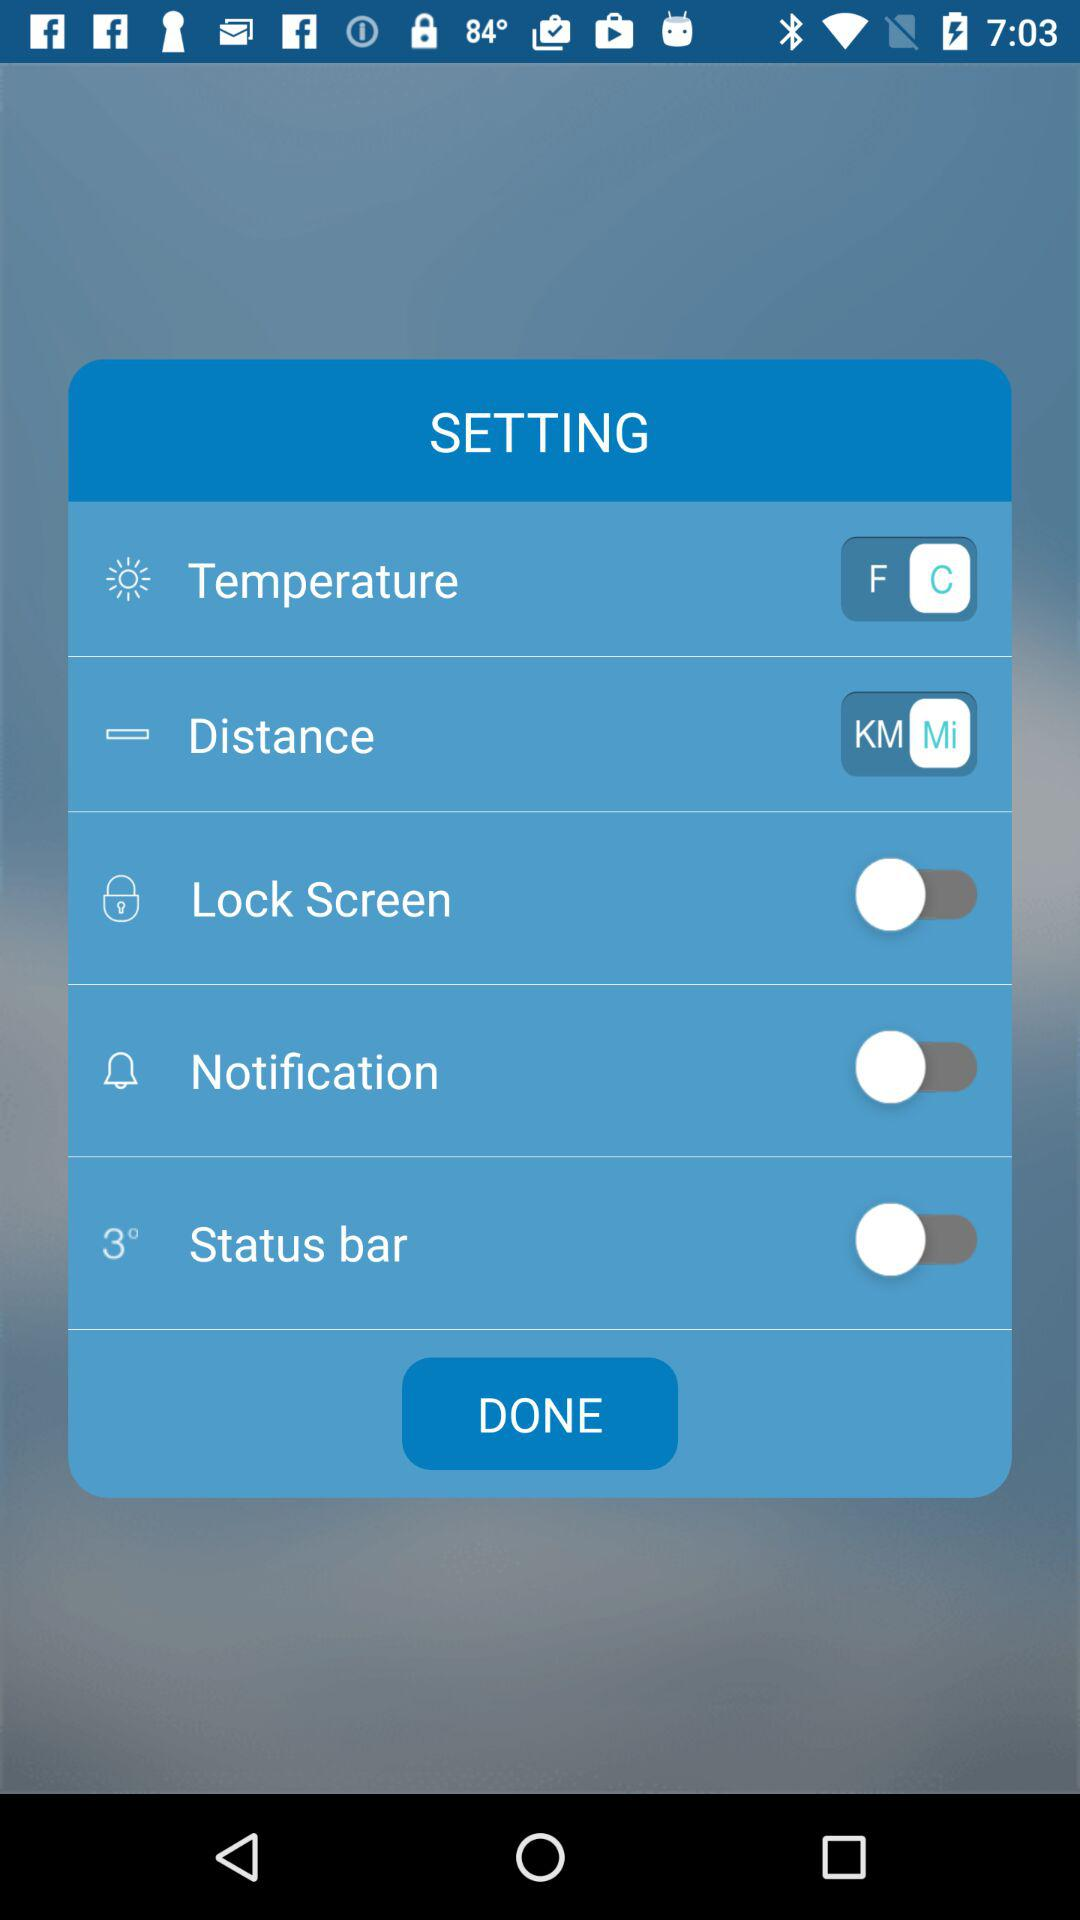What is the selected unit of the distance? The selected unit of the distance is miles. 